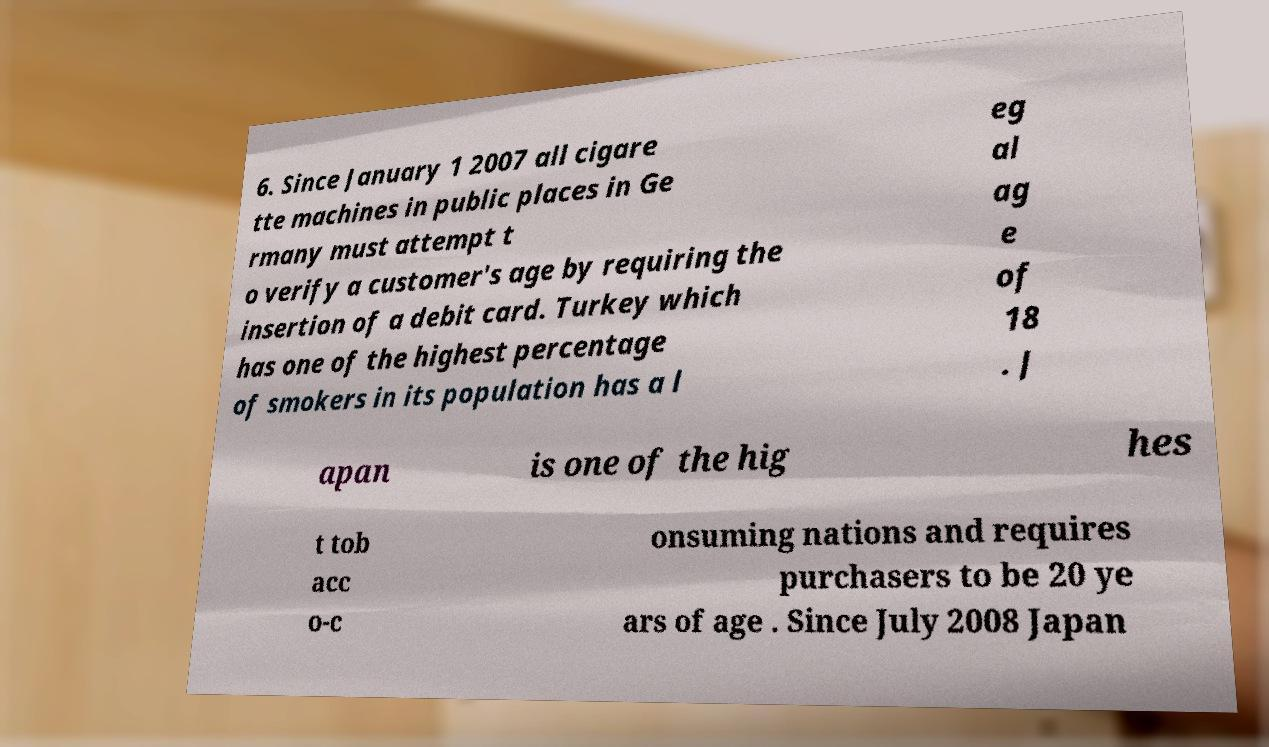For documentation purposes, I need the text within this image transcribed. Could you provide that? 6. Since January 1 2007 all cigare tte machines in public places in Ge rmany must attempt t o verify a customer's age by requiring the insertion of a debit card. Turkey which has one of the highest percentage of smokers in its population has a l eg al ag e of 18 . J apan is one of the hig hes t tob acc o-c onsuming nations and requires purchasers to be 20 ye ars of age . Since July 2008 Japan 